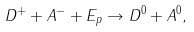Convert formula to latex. <formula><loc_0><loc_0><loc_500><loc_500>D ^ { + } + A ^ { - } + E _ { p } \rightarrow D ^ { 0 } + A ^ { 0 } ,</formula> 